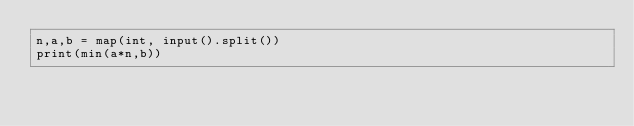<code> <loc_0><loc_0><loc_500><loc_500><_Python_>n,a,b = map(int, input().split())
print(min(a*n,b))</code> 